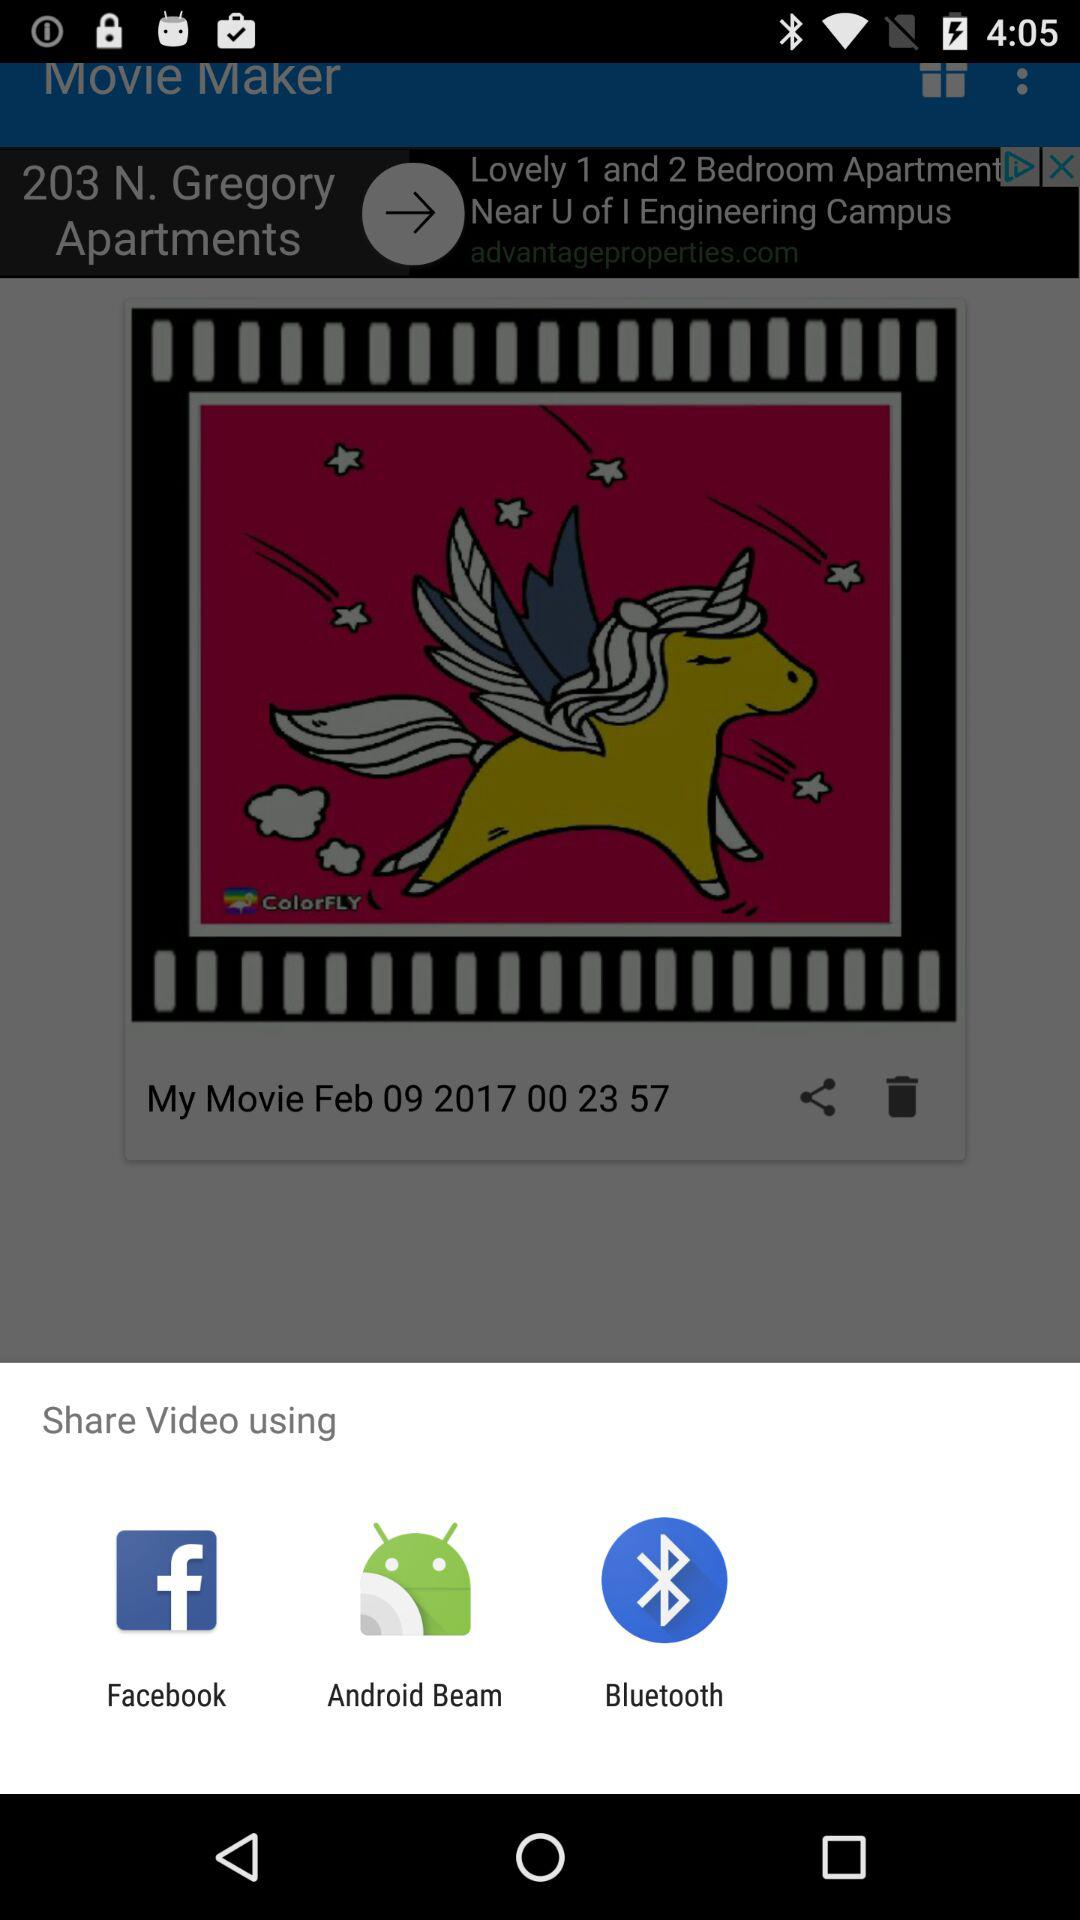Through what applications can we share videos? You can share with "Facebook", "Android Beam" and "Bluetooth". 